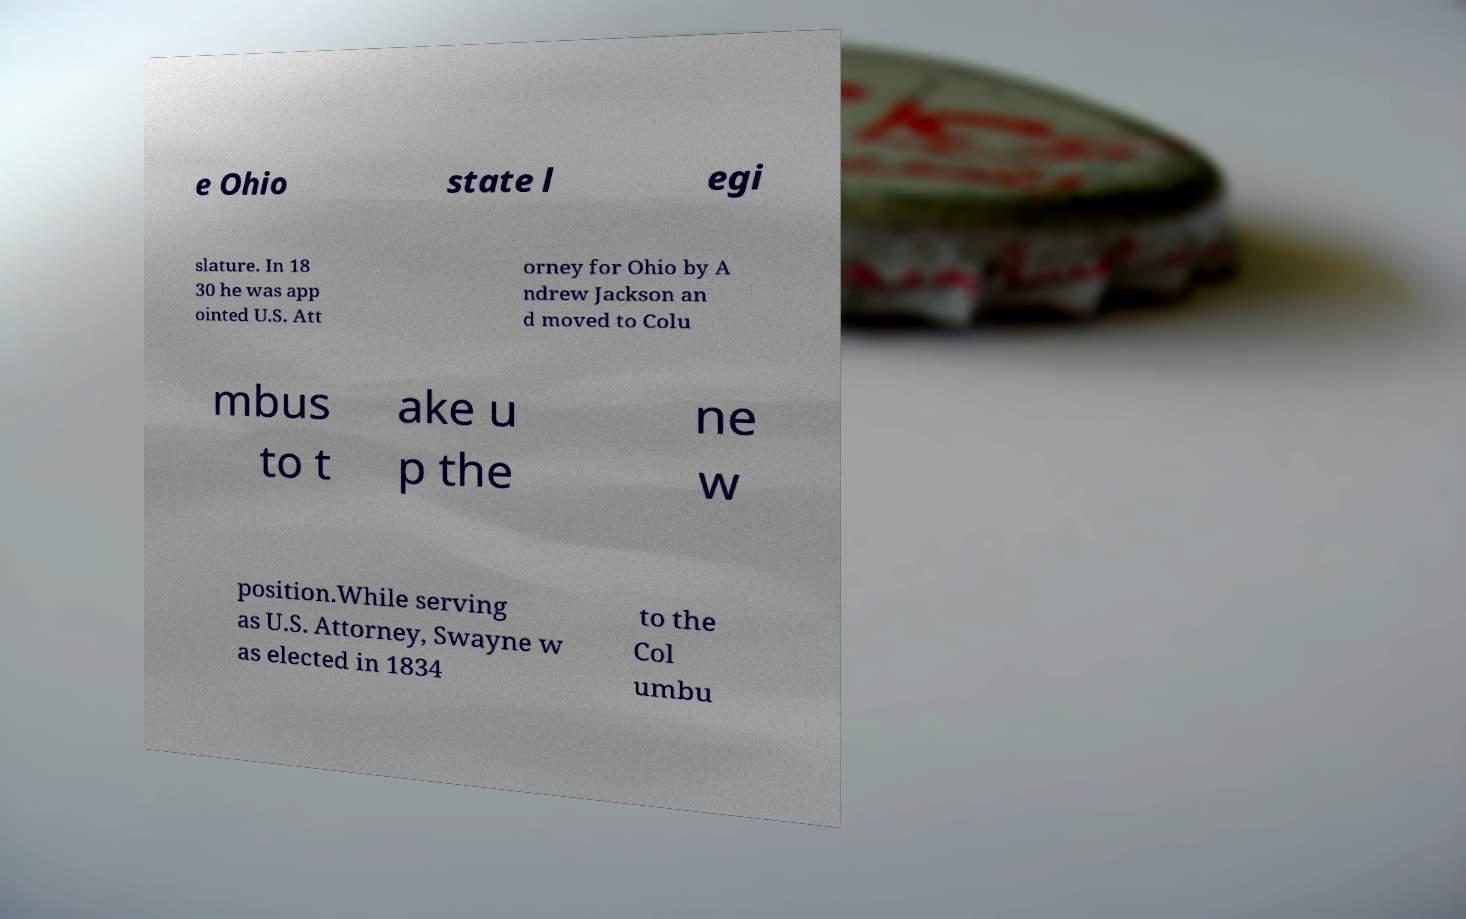Can you read and provide the text displayed in the image?This photo seems to have some interesting text. Can you extract and type it out for me? e Ohio state l egi slature. In 18 30 he was app ointed U.S. Att orney for Ohio by A ndrew Jackson an d moved to Colu mbus to t ake u p the ne w position.While serving as U.S. Attorney, Swayne w as elected in 1834 to the Col umbu 